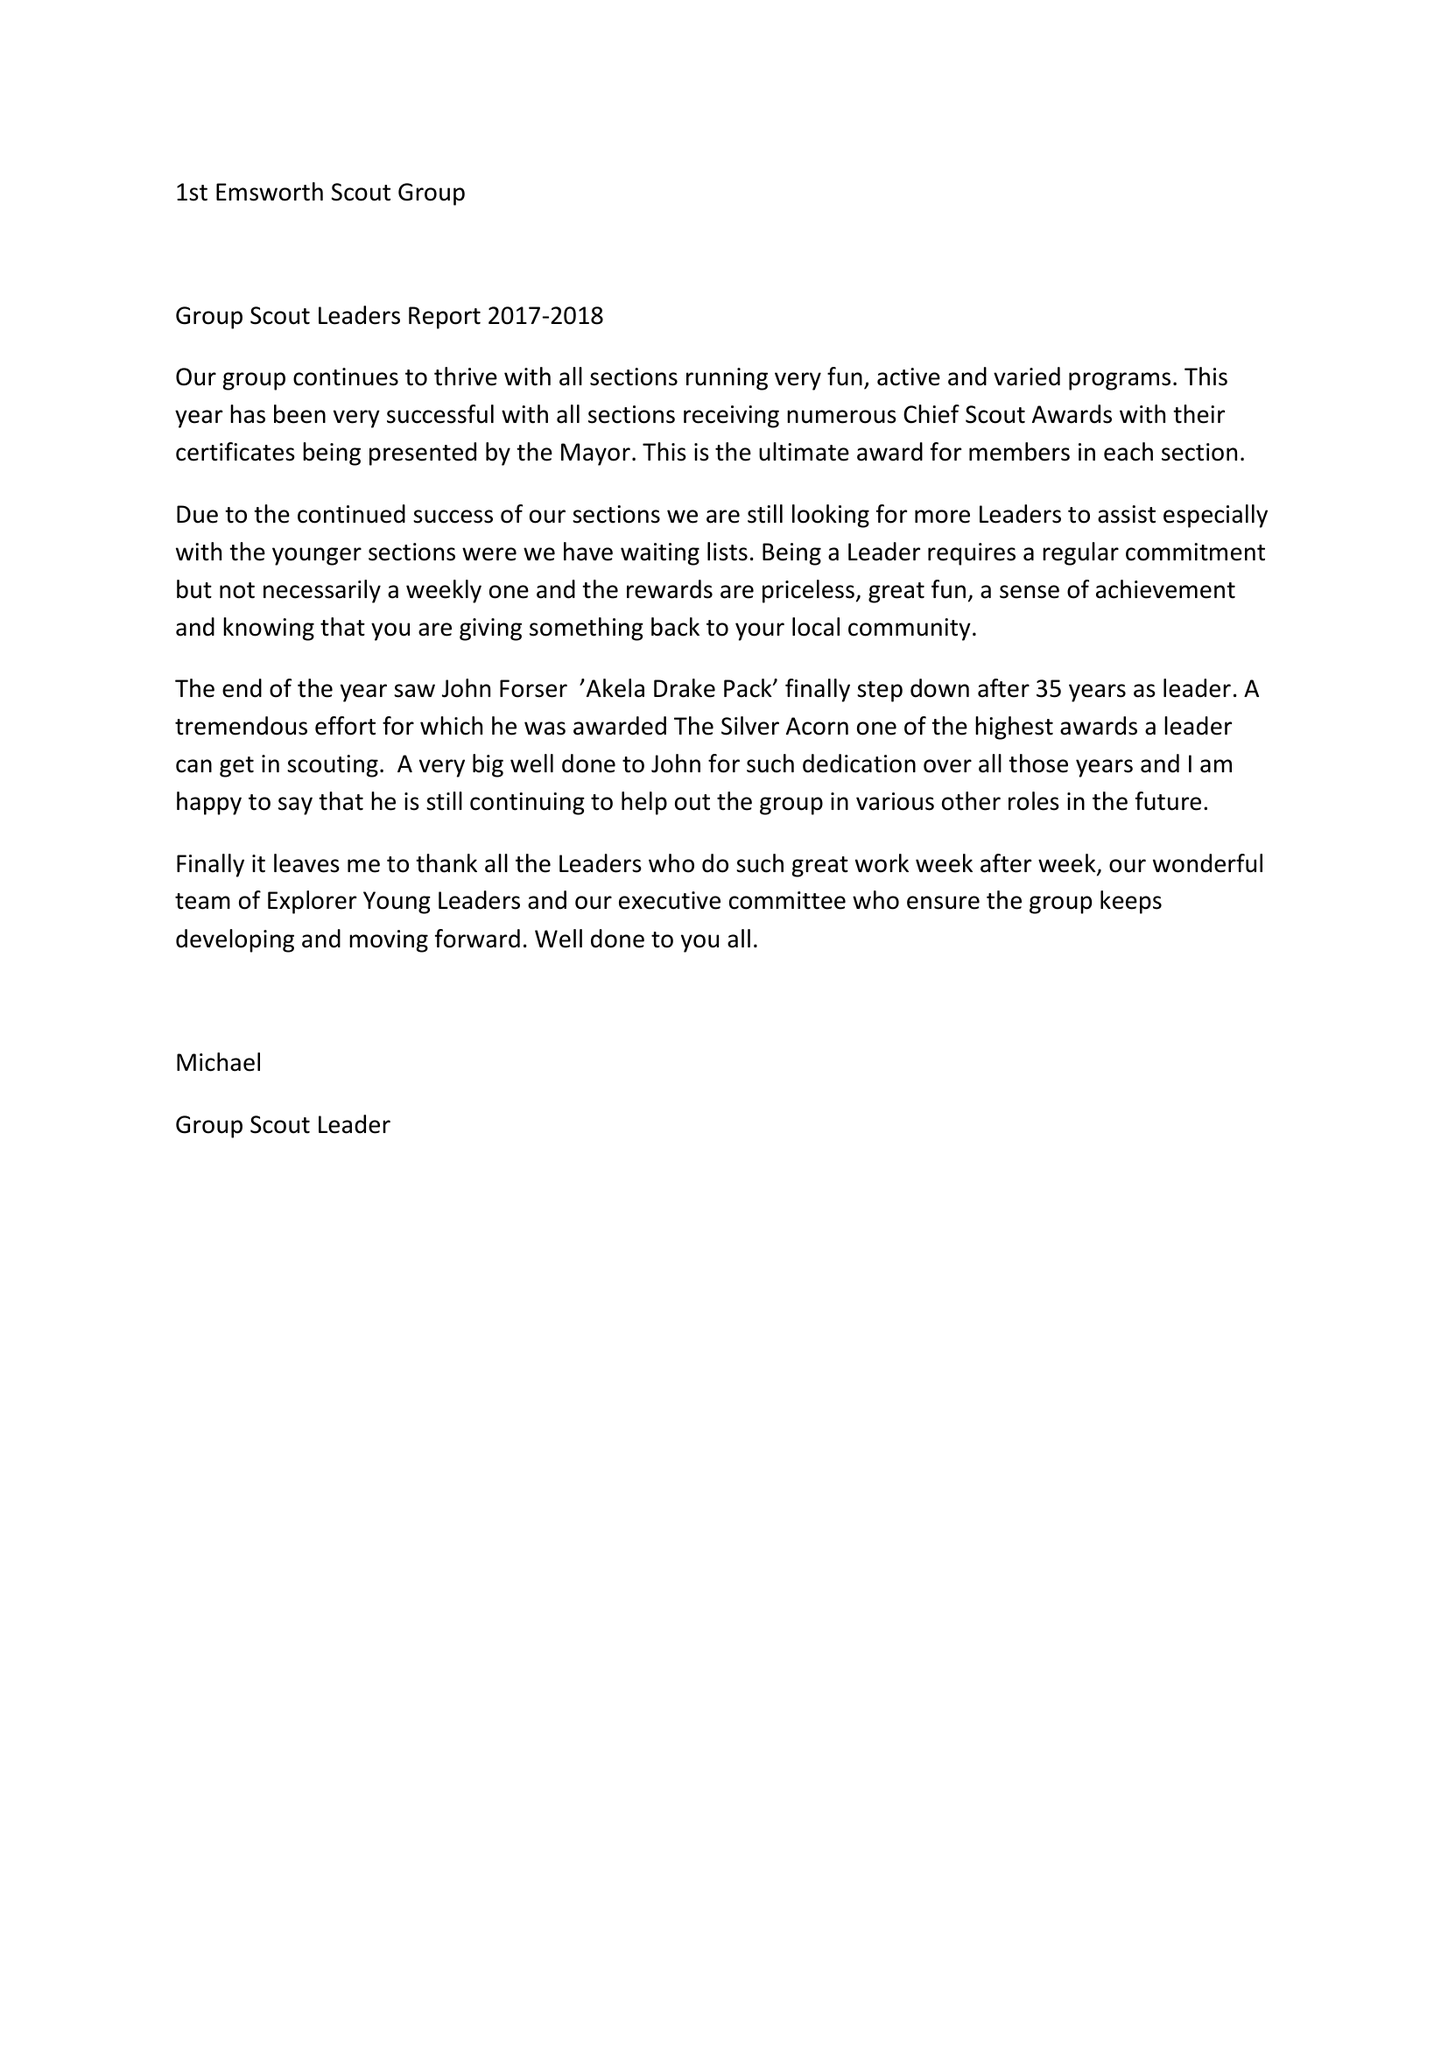What is the value for the charity_name?
Answer the question using a single word or phrase. First Emsworth Scout Group 